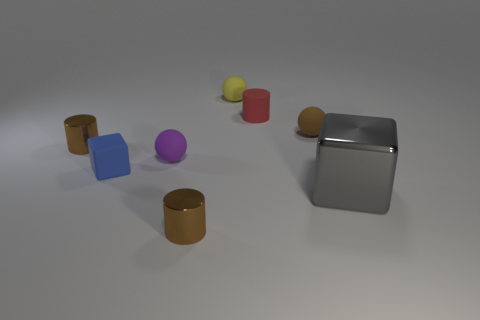Is the tiny yellow object behind the small purple rubber ball made of the same material as the gray cube?
Give a very brief answer. No. How many big red metallic objects are there?
Provide a short and direct response. 0. What number of things are large gray things or small matte cylinders?
Provide a short and direct response. 2. There is a small brown metal cylinder that is in front of the metal cylinder that is to the left of the purple rubber thing; what number of tiny brown metallic things are on the right side of it?
Your answer should be very brief. 0. Are there any other things that have the same color as the matte cylinder?
Give a very brief answer. No. Does the small ball on the left side of the yellow rubber ball have the same color as the matte thing that is on the left side of the small purple matte object?
Keep it short and to the point. No. Are there more tiny purple matte spheres in front of the big gray object than large gray things that are on the left side of the small blue matte thing?
Provide a short and direct response. No. What material is the blue object?
Offer a terse response. Rubber. The brown metal object left of the small brown metallic cylinder in front of the metallic cylinder behind the gray object is what shape?
Provide a succinct answer. Cylinder. What number of other things are made of the same material as the tiny red thing?
Your response must be concise. 4. 